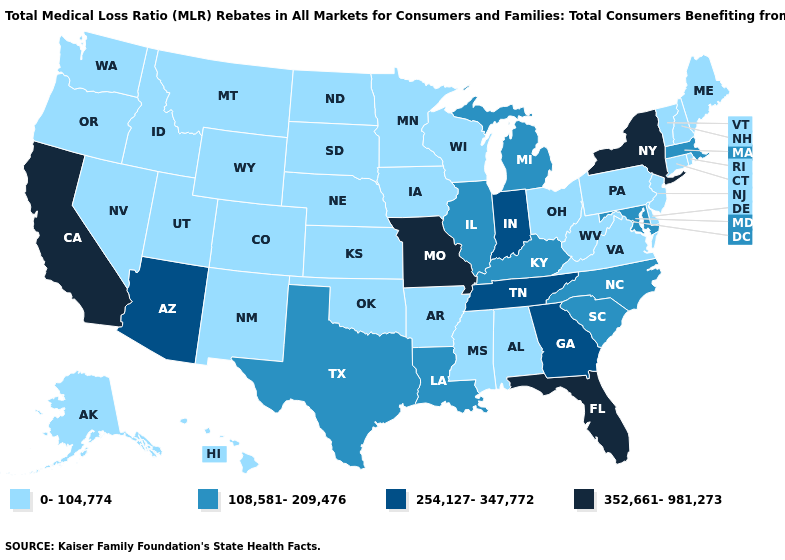Does Maryland have a higher value than New York?
Answer briefly. No. What is the highest value in the USA?
Concise answer only. 352,661-981,273. Among the states that border Pennsylvania , which have the highest value?
Concise answer only. New York. Does Florida have a lower value than South Carolina?
Keep it brief. No. Which states have the highest value in the USA?
Short answer required. California, Florida, Missouri, New York. What is the value of Indiana?
Write a very short answer. 254,127-347,772. Name the states that have a value in the range 108,581-209,476?
Keep it brief. Illinois, Kentucky, Louisiana, Maryland, Massachusetts, Michigan, North Carolina, South Carolina, Texas. What is the highest value in the USA?
Short answer required. 352,661-981,273. What is the value of Nevada?
Short answer required. 0-104,774. How many symbols are there in the legend?
Answer briefly. 4. Does Vermont have the highest value in the Northeast?
Keep it brief. No. Does Wyoming have the same value as North Carolina?
Short answer required. No. Which states have the lowest value in the West?
Give a very brief answer. Alaska, Colorado, Hawaii, Idaho, Montana, Nevada, New Mexico, Oregon, Utah, Washington, Wyoming. Which states have the highest value in the USA?
Keep it brief. California, Florida, Missouri, New York. What is the value of North Dakota?
Keep it brief. 0-104,774. 